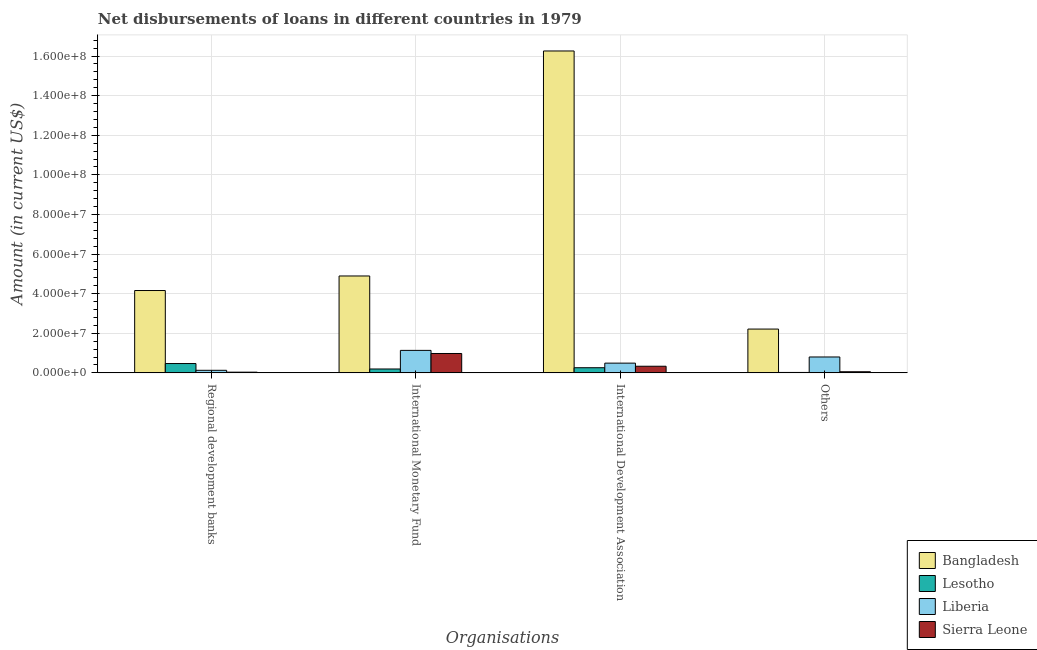How many different coloured bars are there?
Your answer should be compact. 4. How many groups of bars are there?
Ensure brevity in your answer.  4. What is the label of the 2nd group of bars from the left?
Make the answer very short. International Monetary Fund. What is the amount of loan disimbursed by international development association in Bangladesh?
Keep it short and to the point. 1.63e+08. Across all countries, what is the maximum amount of loan disimbursed by other organisations?
Provide a succinct answer. 2.21e+07. Across all countries, what is the minimum amount of loan disimbursed by international monetary fund?
Make the answer very short. 1.96e+06. In which country was the amount of loan disimbursed by regional development banks minimum?
Give a very brief answer. Sierra Leone. What is the total amount of loan disimbursed by regional development banks in the graph?
Make the answer very short. 4.79e+07. What is the difference between the amount of loan disimbursed by international development association in Sierra Leone and that in Lesotho?
Ensure brevity in your answer.  7.56e+05. What is the difference between the amount of loan disimbursed by international monetary fund in Lesotho and the amount of loan disimbursed by regional development banks in Bangladesh?
Ensure brevity in your answer.  -3.96e+07. What is the average amount of loan disimbursed by international monetary fund per country?
Provide a short and direct response. 1.80e+07. What is the difference between the amount of loan disimbursed by other organisations and amount of loan disimbursed by regional development banks in Lesotho?
Offer a very short reply. -4.50e+06. In how many countries, is the amount of loan disimbursed by other organisations greater than 104000000 US$?
Your answer should be compact. 0. What is the ratio of the amount of loan disimbursed by international monetary fund in Bangladesh to that in Lesotho?
Your response must be concise. 25.01. Is the amount of loan disimbursed by regional development banks in Lesotho less than that in Sierra Leone?
Your answer should be very brief. No. Is the difference between the amount of loan disimbursed by international monetary fund in Sierra Leone and Liberia greater than the difference between the amount of loan disimbursed by regional development banks in Sierra Leone and Liberia?
Offer a terse response. No. What is the difference between the highest and the second highest amount of loan disimbursed by other organisations?
Ensure brevity in your answer.  1.41e+07. What is the difference between the highest and the lowest amount of loan disimbursed by regional development banks?
Your answer should be very brief. 4.12e+07. Is the sum of the amount of loan disimbursed by international monetary fund in Sierra Leone and Lesotho greater than the maximum amount of loan disimbursed by regional development banks across all countries?
Ensure brevity in your answer.  No. Is it the case that in every country, the sum of the amount of loan disimbursed by regional development banks and amount of loan disimbursed by other organisations is greater than the sum of amount of loan disimbursed by international monetary fund and amount of loan disimbursed by international development association?
Offer a terse response. No. What does the 2nd bar from the left in International Development Association represents?
Your answer should be very brief. Lesotho. What does the 2nd bar from the right in International Monetary Fund represents?
Give a very brief answer. Liberia. Is it the case that in every country, the sum of the amount of loan disimbursed by regional development banks and amount of loan disimbursed by international monetary fund is greater than the amount of loan disimbursed by international development association?
Make the answer very short. No. Are all the bars in the graph horizontal?
Provide a succinct answer. No. Does the graph contain any zero values?
Keep it short and to the point. No. How many legend labels are there?
Ensure brevity in your answer.  4. What is the title of the graph?
Keep it short and to the point. Net disbursements of loans in different countries in 1979. Does "Upper middle income" appear as one of the legend labels in the graph?
Give a very brief answer. No. What is the label or title of the X-axis?
Offer a very short reply. Organisations. What is the Amount (in current US$) in Bangladesh in Regional development banks?
Ensure brevity in your answer.  4.16e+07. What is the Amount (in current US$) of Lesotho in Regional development banks?
Provide a short and direct response. 4.71e+06. What is the Amount (in current US$) of Liberia in Regional development banks?
Make the answer very short. 1.29e+06. What is the Amount (in current US$) of Sierra Leone in Regional development banks?
Keep it short and to the point. 3.57e+05. What is the Amount (in current US$) in Bangladesh in International Monetary Fund?
Keep it short and to the point. 4.89e+07. What is the Amount (in current US$) of Lesotho in International Monetary Fund?
Give a very brief answer. 1.96e+06. What is the Amount (in current US$) in Liberia in International Monetary Fund?
Your answer should be very brief. 1.14e+07. What is the Amount (in current US$) in Sierra Leone in International Monetary Fund?
Provide a succinct answer. 9.79e+06. What is the Amount (in current US$) of Bangladesh in International Development Association?
Keep it short and to the point. 1.63e+08. What is the Amount (in current US$) in Lesotho in International Development Association?
Give a very brief answer. 2.59e+06. What is the Amount (in current US$) of Liberia in International Development Association?
Provide a short and direct response. 4.92e+06. What is the Amount (in current US$) of Sierra Leone in International Development Association?
Your answer should be very brief. 3.35e+06. What is the Amount (in current US$) in Bangladesh in Others?
Offer a terse response. 2.21e+07. What is the Amount (in current US$) in Lesotho in Others?
Your answer should be compact. 2.12e+05. What is the Amount (in current US$) of Liberia in Others?
Offer a terse response. 8.03e+06. What is the Amount (in current US$) of Sierra Leone in Others?
Your response must be concise. 5.66e+05. Across all Organisations, what is the maximum Amount (in current US$) of Bangladesh?
Make the answer very short. 1.63e+08. Across all Organisations, what is the maximum Amount (in current US$) in Lesotho?
Offer a terse response. 4.71e+06. Across all Organisations, what is the maximum Amount (in current US$) in Liberia?
Your answer should be compact. 1.14e+07. Across all Organisations, what is the maximum Amount (in current US$) of Sierra Leone?
Ensure brevity in your answer.  9.79e+06. Across all Organisations, what is the minimum Amount (in current US$) of Bangladesh?
Offer a very short reply. 2.21e+07. Across all Organisations, what is the minimum Amount (in current US$) in Lesotho?
Provide a succinct answer. 2.12e+05. Across all Organisations, what is the minimum Amount (in current US$) of Liberia?
Offer a terse response. 1.29e+06. Across all Organisations, what is the minimum Amount (in current US$) in Sierra Leone?
Give a very brief answer. 3.57e+05. What is the total Amount (in current US$) of Bangladesh in the graph?
Ensure brevity in your answer.  2.75e+08. What is the total Amount (in current US$) in Lesotho in the graph?
Your answer should be very brief. 9.48e+06. What is the total Amount (in current US$) of Liberia in the graph?
Make the answer very short. 2.56e+07. What is the total Amount (in current US$) in Sierra Leone in the graph?
Your answer should be compact. 1.41e+07. What is the difference between the Amount (in current US$) in Bangladesh in Regional development banks and that in International Monetary Fund?
Give a very brief answer. -7.35e+06. What is the difference between the Amount (in current US$) of Lesotho in Regional development banks and that in International Monetary Fund?
Make the answer very short. 2.76e+06. What is the difference between the Amount (in current US$) in Liberia in Regional development banks and that in International Monetary Fund?
Make the answer very short. -1.01e+07. What is the difference between the Amount (in current US$) in Sierra Leone in Regional development banks and that in International Monetary Fund?
Ensure brevity in your answer.  -9.43e+06. What is the difference between the Amount (in current US$) of Bangladesh in Regional development banks and that in International Development Association?
Offer a very short reply. -1.21e+08. What is the difference between the Amount (in current US$) of Lesotho in Regional development banks and that in International Development Association?
Your answer should be very brief. 2.12e+06. What is the difference between the Amount (in current US$) in Liberia in Regional development banks and that in International Development Association?
Provide a short and direct response. -3.62e+06. What is the difference between the Amount (in current US$) of Sierra Leone in Regional development banks and that in International Development Association?
Ensure brevity in your answer.  -2.99e+06. What is the difference between the Amount (in current US$) in Bangladesh in Regional development banks and that in Others?
Ensure brevity in your answer.  1.95e+07. What is the difference between the Amount (in current US$) in Lesotho in Regional development banks and that in Others?
Your response must be concise. 4.50e+06. What is the difference between the Amount (in current US$) of Liberia in Regional development banks and that in Others?
Give a very brief answer. -6.74e+06. What is the difference between the Amount (in current US$) in Sierra Leone in Regional development banks and that in Others?
Keep it short and to the point. -2.09e+05. What is the difference between the Amount (in current US$) of Bangladesh in International Monetary Fund and that in International Development Association?
Offer a terse response. -1.14e+08. What is the difference between the Amount (in current US$) in Lesotho in International Monetary Fund and that in International Development Association?
Make the answer very short. -6.36e+05. What is the difference between the Amount (in current US$) of Liberia in International Monetary Fund and that in International Development Association?
Your answer should be very brief. 6.44e+06. What is the difference between the Amount (in current US$) in Sierra Leone in International Monetary Fund and that in International Development Association?
Ensure brevity in your answer.  6.44e+06. What is the difference between the Amount (in current US$) in Bangladesh in International Monetary Fund and that in Others?
Keep it short and to the point. 2.68e+07. What is the difference between the Amount (in current US$) of Lesotho in International Monetary Fund and that in Others?
Ensure brevity in your answer.  1.74e+06. What is the difference between the Amount (in current US$) in Liberia in International Monetary Fund and that in Others?
Your answer should be compact. 3.33e+06. What is the difference between the Amount (in current US$) in Sierra Leone in International Monetary Fund and that in Others?
Make the answer very short. 9.22e+06. What is the difference between the Amount (in current US$) of Bangladesh in International Development Association and that in Others?
Give a very brief answer. 1.40e+08. What is the difference between the Amount (in current US$) of Lesotho in International Development Association and that in Others?
Offer a very short reply. 2.38e+06. What is the difference between the Amount (in current US$) of Liberia in International Development Association and that in Others?
Make the answer very short. -3.11e+06. What is the difference between the Amount (in current US$) of Sierra Leone in International Development Association and that in Others?
Ensure brevity in your answer.  2.78e+06. What is the difference between the Amount (in current US$) in Bangladesh in Regional development banks and the Amount (in current US$) in Lesotho in International Monetary Fund?
Make the answer very short. 3.96e+07. What is the difference between the Amount (in current US$) of Bangladesh in Regional development banks and the Amount (in current US$) of Liberia in International Monetary Fund?
Give a very brief answer. 3.02e+07. What is the difference between the Amount (in current US$) of Bangladesh in Regional development banks and the Amount (in current US$) of Sierra Leone in International Monetary Fund?
Offer a very short reply. 3.18e+07. What is the difference between the Amount (in current US$) in Lesotho in Regional development banks and the Amount (in current US$) in Liberia in International Monetary Fund?
Offer a very short reply. -6.64e+06. What is the difference between the Amount (in current US$) in Lesotho in Regional development banks and the Amount (in current US$) in Sierra Leone in International Monetary Fund?
Keep it short and to the point. -5.07e+06. What is the difference between the Amount (in current US$) of Liberia in Regional development banks and the Amount (in current US$) of Sierra Leone in International Monetary Fund?
Your response must be concise. -8.50e+06. What is the difference between the Amount (in current US$) of Bangladesh in Regional development banks and the Amount (in current US$) of Lesotho in International Development Association?
Keep it short and to the point. 3.90e+07. What is the difference between the Amount (in current US$) in Bangladesh in Regional development banks and the Amount (in current US$) in Liberia in International Development Association?
Make the answer very short. 3.67e+07. What is the difference between the Amount (in current US$) of Bangladesh in Regional development banks and the Amount (in current US$) of Sierra Leone in International Development Association?
Ensure brevity in your answer.  3.82e+07. What is the difference between the Amount (in current US$) in Lesotho in Regional development banks and the Amount (in current US$) in Liberia in International Development Association?
Give a very brief answer. -2.04e+05. What is the difference between the Amount (in current US$) of Lesotho in Regional development banks and the Amount (in current US$) of Sierra Leone in International Development Association?
Give a very brief answer. 1.36e+06. What is the difference between the Amount (in current US$) of Liberia in Regional development banks and the Amount (in current US$) of Sierra Leone in International Development Association?
Give a very brief answer. -2.06e+06. What is the difference between the Amount (in current US$) of Bangladesh in Regional development banks and the Amount (in current US$) of Lesotho in Others?
Offer a very short reply. 4.14e+07. What is the difference between the Amount (in current US$) of Bangladesh in Regional development banks and the Amount (in current US$) of Liberia in Others?
Make the answer very short. 3.36e+07. What is the difference between the Amount (in current US$) in Bangladesh in Regional development banks and the Amount (in current US$) in Sierra Leone in Others?
Provide a short and direct response. 4.10e+07. What is the difference between the Amount (in current US$) in Lesotho in Regional development banks and the Amount (in current US$) in Liberia in Others?
Provide a short and direct response. -3.31e+06. What is the difference between the Amount (in current US$) of Lesotho in Regional development banks and the Amount (in current US$) of Sierra Leone in Others?
Your response must be concise. 4.15e+06. What is the difference between the Amount (in current US$) of Liberia in Regional development banks and the Amount (in current US$) of Sierra Leone in Others?
Your response must be concise. 7.26e+05. What is the difference between the Amount (in current US$) in Bangladesh in International Monetary Fund and the Amount (in current US$) in Lesotho in International Development Association?
Offer a terse response. 4.63e+07. What is the difference between the Amount (in current US$) of Bangladesh in International Monetary Fund and the Amount (in current US$) of Liberia in International Development Association?
Make the answer very short. 4.40e+07. What is the difference between the Amount (in current US$) in Bangladesh in International Monetary Fund and the Amount (in current US$) in Sierra Leone in International Development Association?
Your answer should be very brief. 4.56e+07. What is the difference between the Amount (in current US$) of Lesotho in International Monetary Fund and the Amount (in current US$) of Liberia in International Development Association?
Keep it short and to the point. -2.96e+06. What is the difference between the Amount (in current US$) in Lesotho in International Monetary Fund and the Amount (in current US$) in Sierra Leone in International Development Association?
Provide a succinct answer. -1.39e+06. What is the difference between the Amount (in current US$) of Liberia in International Monetary Fund and the Amount (in current US$) of Sierra Leone in International Development Association?
Provide a short and direct response. 8.00e+06. What is the difference between the Amount (in current US$) in Bangladesh in International Monetary Fund and the Amount (in current US$) in Lesotho in Others?
Your response must be concise. 4.87e+07. What is the difference between the Amount (in current US$) in Bangladesh in International Monetary Fund and the Amount (in current US$) in Liberia in Others?
Provide a succinct answer. 4.09e+07. What is the difference between the Amount (in current US$) of Bangladesh in International Monetary Fund and the Amount (in current US$) of Sierra Leone in Others?
Keep it short and to the point. 4.84e+07. What is the difference between the Amount (in current US$) in Lesotho in International Monetary Fund and the Amount (in current US$) in Liberia in Others?
Give a very brief answer. -6.07e+06. What is the difference between the Amount (in current US$) in Lesotho in International Monetary Fund and the Amount (in current US$) in Sierra Leone in Others?
Give a very brief answer. 1.39e+06. What is the difference between the Amount (in current US$) of Liberia in International Monetary Fund and the Amount (in current US$) of Sierra Leone in Others?
Offer a terse response. 1.08e+07. What is the difference between the Amount (in current US$) in Bangladesh in International Development Association and the Amount (in current US$) in Lesotho in Others?
Make the answer very short. 1.62e+08. What is the difference between the Amount (in current US$) of Bangladesh in International Development Association and the Amount (in current US$) of Liberia in Others?
Your answer should be very brief. 1.55e+08. What is the difference between the Amount (in current US$) in Bangladesh in International Development Association and the Amount (in current US$) in Sierra Leone in Others?
Offer a terse response. 1.62e+08. What is the difference between the Amount (in current US$) in Lesotho in International Development Association and the Amount (in current US$) in Liberia in Others?
Provide a succinct answer. -5.43e+06. What is the difference between the Amount (in current US$) of Lesotho in International Development Association and the Amount (in current US$) of Sierra Leone in Others?
Offer a terse response. 2.03e+06. What is the difference between the Amount (in current US$) of Liberia in International Development Association and the Amount (in current US$) of Sierra Leone in Others?
Your response must be concise. 4.35e+06. What is the average Amount (in current US$) of Bangladesh per Organisations?
Offer a very short reply. 6.88e+07. What is the average Amount (in current US$) of Lesotho per Organisations?
Provide a succinct answer. 2.37e+06. What is the average Amount (in current US$) in Liberia per Organisations?
Ensure brevity in your answer.  6.40e+06. What is the average Amount (in current US$) in Sierra Leone per Organisations?
Keep it short and to the point. 3.51e+06. What is the difference between the Amount (in current US$) in Bangladesh and Amount (in current US$) in Lesotho in Regional development banks?
Offer a very short reply. 3.69e+07. What is the difference between the Amount (in current US$) of Bangladesh and Amount (in current US$) of Liberia in Regional development banks?
Provide a short and direct response. 4.03e+07. What is the difference between the Amount (in current US$) of Bangladesh and Amount (in current US$) of Sierra Leone in Regional development banks?
Your response must be concise. 4.12e+07. What is the difference between the Amount (in current US$) in Lesotho and Amount (in current US$) in Liberia in Regional development banks?
Your answer should be compact. 3.42e+06. What is the difference between the Amount (in current US$) in Lesotho and Amount (in current US$) in Sierra Leone in Regional development banks?
Keep it short and to the point. 4.36e+06. What is the difference between the Amount (in current US$) of Liberia and Amount (in current US$) of Sierra Leone in Regional development banks?
Your answer should be compact. 9.35e+05. What is the difference between the Amount (in current US$) of Bangladesh and Amount (in current US$) of Lesotho in International Monetary Fund?
Your answer should be compact. 4.70e+07. What is the difference between the Amount (in current US$) in Bangladesh and Amount (in current US$) in Liberia in International Monetary Fund?
Make the answer very short. 3.76e+07. What is the difference between the Amount (in current US$) in Bangladesh and Amount (in current US$) in Sierra Leone in International Monetary Fund?
Your response must be concise. 3.91e+07. What is the difference between the Amount (in current US$) of Lesotho and Amount (in current US$) of Liberia in International Monetary Fund?
Offer a terse response. -9.40e+06. What is the difference between the Amount (in current US$) of Lesotho and Amount (in current US$) of Sierra Leone in International Monetary Fund?
Offer a terse response. -7.83e+06. What is the difference between the Amount (in current US$) of Liberia and Amount (in current US$) of Sierra Leone in International Monetary Fund?
Your response must be concise. 1.57e+06. What is the difference between the Amount (in current US$) of Bangladesh and Amount (in current US$) of Lesotho in International Development Association?
Provide a short and direct response. 1.60e+08. What is the difference between the Amount (in current US$) in Bangladesh and Amount (in current US$) in Liberia in International Development Association?
Ensure brevity in your answer.  1.58e+08. What is the difference between the Amount (in current US$) in Bangladesh and Amount (in current US$) in Sierra Leone in International Development Association?
Your answer should be compact. 1.59e+08. What is the difference between the Amount (in current US$) of Lesotho and Amount (in current US$) of Liberia in International Development Association?
Give a very brief answer. -2.32e+06. What is the difference between the Amount (in current US$) of Lesotho and Amount (in current US$) of Sierra Leone in International Development Association?
Make the answer very short. -7.56e+05. What is the difference between the Amount (in current US$) of Liberia and Amount (in current US$) of Sierra Leone in International Development Association?
Give a very brief answer. 1.57e+06. What is the difference between the Amount (in current US$) of Bangladesh and Amount (in current US$) of Lesotho in Others?
Your answer should be very brief. 2.19e+07. What is the difference between the Amount (in current US$) in Bangladesh and Amount (in current US$) in Liberia in Others?
Provide a succinct answer. 1.41e+07. What is the difference between the Amount (in current US$) in Bangladesh and Amount (in current US$) in Sierra Leone in Others?
Ensure brevity in your answer.  2.16e+07. What is the difference between the Amount (in current US$) in Lesotho and Amount (in current US$) in Liberia in Others?
Your response must be concise. -7.82e+06. What is the difference between the Amount (in current US$) of Lesotho and Amount (in current US$) of Sierra Leone in Others?
Offer a terse response. -3.54e+05. What is the difference between the Amount (in current US$) in Liberia and Amount (in current US$) in Sierra Leone in Others?
Give a very brief answer. 7.46e+06. What is the ratio of the Amount (in current US$) in Bangladesh in Regional development banks to that in International Monetary Fund?
Offer a very short reply. 0.85. What is the ratio of the Amount (in current US$) of Lesotho in Regional development banks to that in International Monetary Fund?
Your answer should be very brief. 2.41. What is the ratio of the Amount (in current US$) in Liberia in Regional development banks to that in International Monetary Fund?
Your response must be concise. 0.11. What is the ratio of the Amount (in current US$) in Sierra Leone in Regional development banks to that in International Monetary Fund?
Your response must be concise. 0.04. What is the ratio of the Amount (in current US$) in Bangladesh in Regional development banks to that in International Development Association?
Give a very brief answer. 0.26. What is the ratio of the Amount (in current US$) of Lesotho in Regional development banks to that in International Development Association?
Your answer should be very brief. 1.82. What is the ratio of the Amount (in current US$) of Liberia in Regional development banks to that in International Development Association?
Your response must be concise. 0.26. What is the ratio of the Amount (in current US$) of Sierra Leone in Regional development banks to that in International Development Association?
Make the answer very short. 0.11. What is the ratio of the Amount (in current US$) in Bangladesh in Regional development banks to that in Others?
Your response must be concise. 1.88. What is the ratio of the Amount (in current US$) in Lesotho in Regional development banks to that in Others?
Offer a terse response. 22.23. What is the ratio of the Amount (in current US$) in Liberia in Regional development banks to that in Others?
Your answer should be compact. 0.16. What is the ratio of the Amount (in current US$) of Sierra Leone in Regional development banks to that in Others?
Provide a succinct answer. 0.63. What is the ratio of the Amount (in current US$) in Bangladesh in International Monetary Fund to that in International Development Association?
Offer a terse response. 0.3. What is the ratio of the Amount (in current US$) in Lesotho in International Monetary Fund to that in International Development Association?
Offer a very short reply. 0.75. What is the ratio of the Amount (in current US$) in Liberia in International Monetary Fund to that in International Development Association?
Your answer should be compact. 2.31. What is the ratio of the Amount (in current US$) in Sierra Leone in International Monetary Fund to that in International Development Association?
Your answer should be very brief. 2.92. What is the ratio of the Amount (in current US$) of Bangladesh in International Monetary Fund to that in Others?
Keep it short and to the point. 2.21. What is the ratio of the Amount (in current US$) in Lesotho in International Monetary Fund to that in Others?
Provide a succinct answer. 9.23. What is the ratio of the Amount (in current US$) of Liberia in International Monetary Fund to that in Others?
Provide a short and direct response. 1.41. What is the ratio of the Amount (in current US$) of Sierra Leone in International Monetary Fund to that in Others?
Ensure brevity in your answer.  17.29. What is the ratio of the Amount (in current US$) of Bangladesh in International Development Association to that in Others?
Your answer should be very brief. 7.35. What is the ratio of the Amount (in current US$) of Lesotho in International Development Association to that in Others?
Your response must be concise. 12.23. What is the ratio of the Amount (in current US$) in Liberia in International Development Association to that in Others?
Offer a very short reply. 0.61. What is the ratio of the Amount (in current US$) in Sierra Leone in International Development Association to that in Others?
Offer a very short reply. 5.92. What is the difference between the highest and the second highest Amount (in current US$) of Bangladesh?
Your answer should be compact. 1.14e+08. What is the difference between the highest and the second highest Amount (in current US$) of Lesotho?
Ensure brevity in your answer.  2.12e+06. What is the difference between the highest and the second highest Amount (in current US$) of Liberia?
Ensure brevity in your answer.  3.33e+06. What is the difference between the highest and the second highest Amount (in current US$) in Sierra Leone?
Your answer should be very brief. 6.44e+06. What is the difference between the highest and the lowest Amount (in current US$) of Bangladesh?
Keep it short and to the point. 1.40e+08. What is the difference between the highest and the lowest Amount (in current US$) of Lesotho?
Make the answer very short. 4.50e+06. What is the difference between the highest and the lowest Amount (in current US$) in Liberia?
Make the answer very short. 1.01e+07. What is the difference between the highest and the lowest Amount (in current US$) in Sierra Leone?
Your response must be concise. 9.43e+06. 